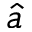Convert formula to latex. <formula><loc_0><loc_0><loc_500><loc_500>\hat { a }</formula> 